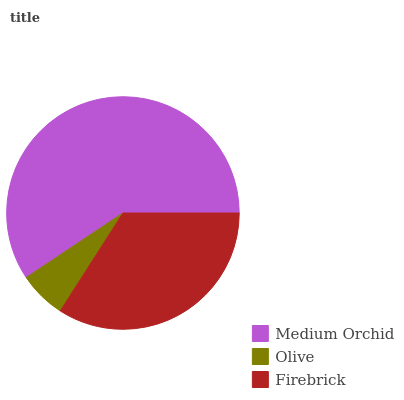Is Olive the minimum?
Answer yes or no. Yes. Is Medium Orchid the maximum?
Answer yes or no. Yes. Is Firebrick the minimum?
Answer yes or no. No. Is Firebrick the maximum?
Answer yes or no. No. Is Firebrick greater than Olive?
Answer yes or no. Yes. Is Olive less than Firebrick?
Answer yes or no. Yes. Is Olive greater than Firebrick?
Answer yes or no. No. Is Firebrick less than Olive?
Answer yes or no. No. Is Firebrick the high median?
Answer yes or no. Yes. Is Firebrick the low median?
Answer yes or no. Yes. Is Olive the high median?
Answer yes or no. No. Is Medium Orchid the low median?
Answer yes or no. No. 